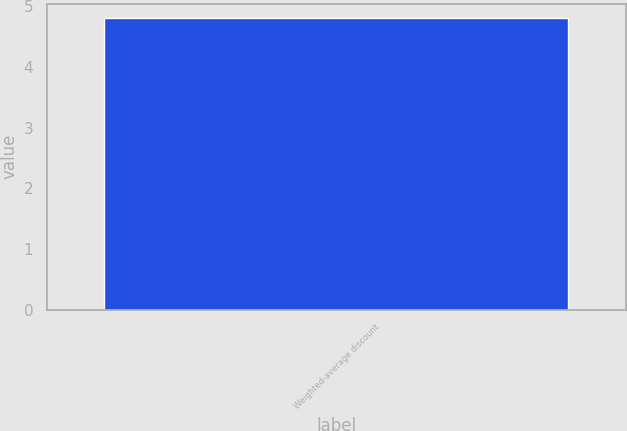<chart> <loc_0><loc_0><loc_500><loc_500><bar_chart><fcel>Weighted-average discount<nl><fcel>4.8<nl></chart> 